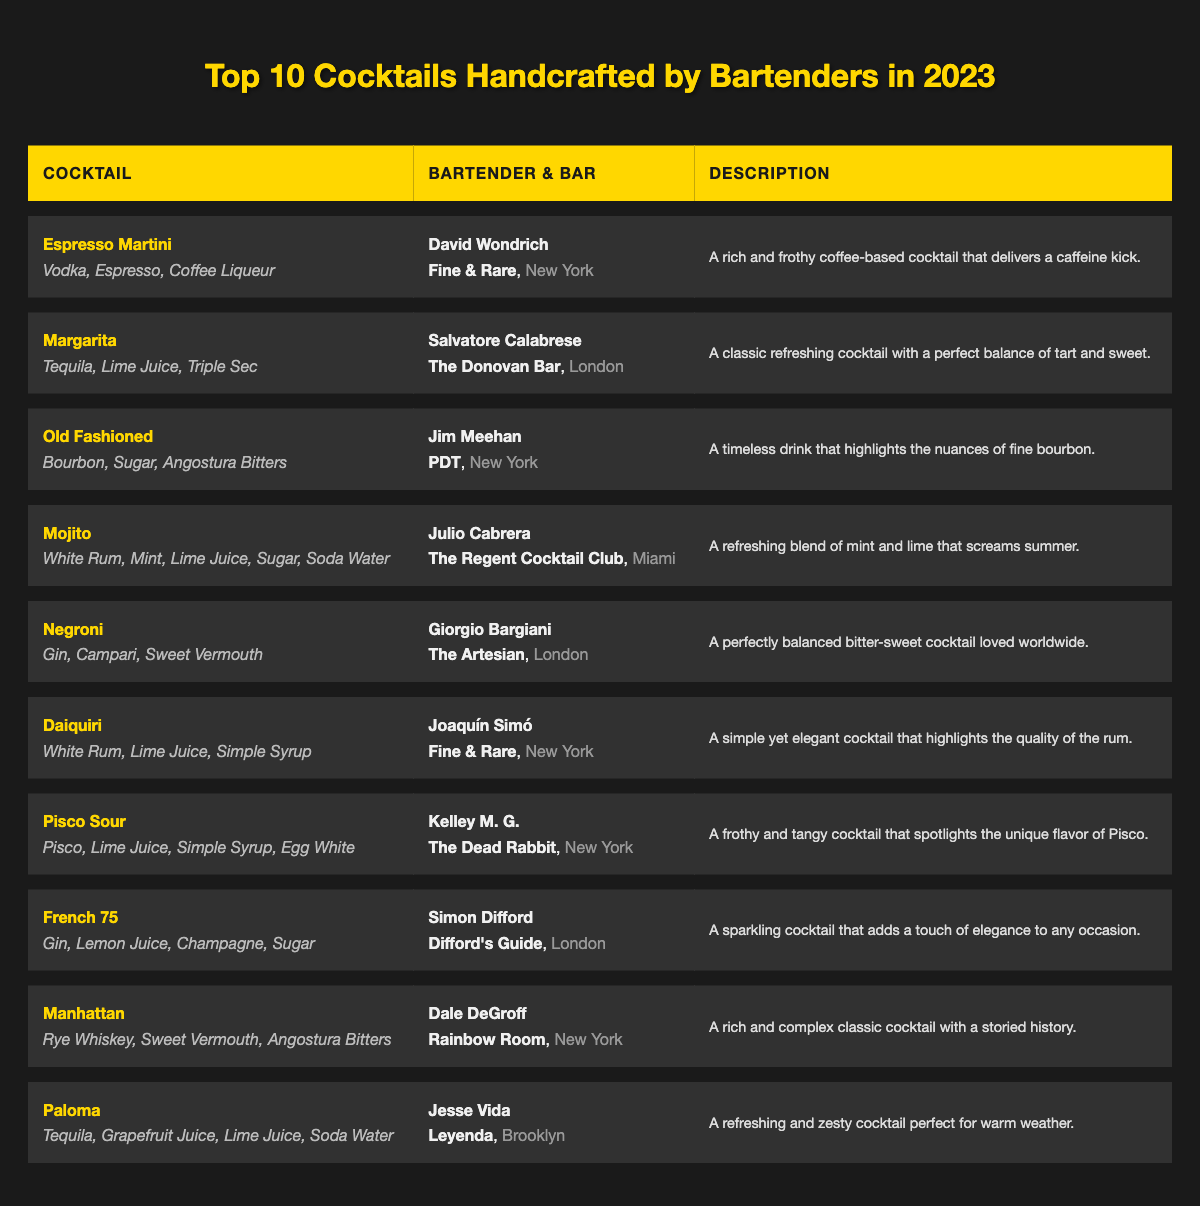What is the name of the cocktail made by David Wondrich? According to the table, David Wondrich crafted the "Espresso Martini," which is listed under his name.
Answer: Espresso Martini Which city is associated with the cocktail "Margarita"? The "Margarita" cocktail is created by Salvatore Calabrese and is served at The Donovan Bar, which is located in London.
Answer: London How many cocktails feature tequila as a main ingredient? The table lists two cocktails with tequila: "Margarita" and "Paloma." Therefore, the total number is 2.
Answer: 2 What description is given for the "Negroni"? The table states that the "Negroni" is "A perfectly balanced bitter-sweet cocktail loved worldwide," according to the description column.
Answer: A perfectly balanced bitter-sweet cocktail loved worldwide Which cocktail is associated with the most locations? The table lists three cocktails associated with New York City: "Espresso Martini," "Old Fashioned," and "Daiquiri." Hence, New York has the most cocktails at 3.
Answer: New York Who is the bartender for the cocktail that describes itself as "A frothy and tangy cocktail that spotlights the unique flavor of Pisco"? The description provided matches the "Pisco Sour," which is made by bartender Kelley M. G. at The Dead Rabbit.
Answer: Kelley M. G Is the "French 75" crafted by a bartender based in the United States? The "French 75" is made by Simon Difford, who works at Difford's Guide, based in London. Therefore, this statement is false.
Answer: No What are the main ingredients of the cocktail that is described as "A simple yet elegant cocktail that highlights the quality of the rum"? This description relates to the "Daiquiri," and its main ingredients are: White Rum, Lime Juice, and Simple Syrup, as shown in the table.
Answer: White Rum, Lime Juice, Simple Syrup Determine the number of cocktails that include lime juice as an ingredient. By reviewing the table, the cocktails that contain lime juice are: "Margarita," "Mojito," "Daiquiri," "Pisco Sour," "French 75," and "Paloma," totaling 6 cocktails.
Answer: 6 Which cocktail features the combination of gin, lemon juice, and champagne? The "French 75" contains gin, lemon juice, and champagne as its main ingredients, as indicated in the ingredients section of the table.
Answer: French 75 